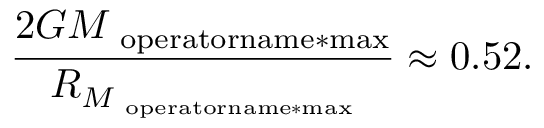Convert formula to latex. <formula><loc_0><loc_0><loc_500><loc_500>{ \frac { 2 G { M } _ { \ o p e r a t o r n a m e * { \max } } } { { R } _ { { M } _ { \ o p e r a t o r n a m e * { \max } } } } } \approx 0 . 5 2 .</formula> 